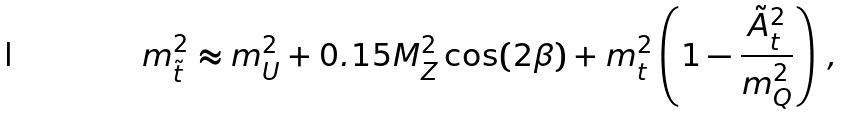Convert formula to latex. <formula><loc_0><loc_0><loc_500><loc_500>m ^ { 2 } _ { \tilde { t } } \approx m ^ { 2 } _ { U } + 0 . 1 5 M ^ { 2 } _ { Z } \cos ( 2 \beta ) + m ^ { 2 } _ { t } \left ( 1 - \frac { { \tilde { A } } ^ { 2 } _ { t } } { m ^ { 2 } _ { Q } } \right ) \, ,</formula> 